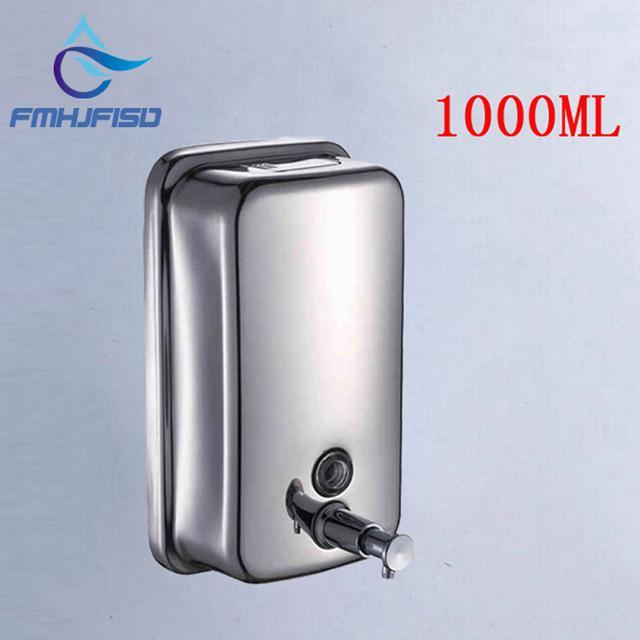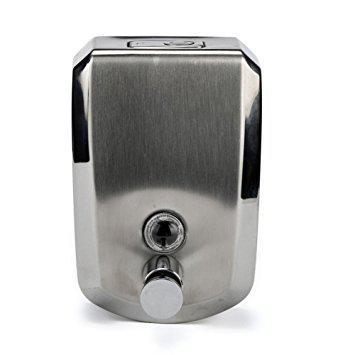The first image is the image on the left, the second image is the image on the right. Analyze the images presented: Is the assertion "There are exactly two all metal dispensers." valid? Answer yes or no. Yes. The first image is the image on the left, the second image is the image on the right. For the images displayed, is the sentence "there is a soap dispenser with a thumb pushing the dispenser plunger" factually correct? Answer yes or no. No. 